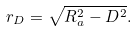Convert formula to latex. <formula><loc_0><loc_0><loc_500><loc_500>r _ { D } = \sqrt { R _ { a } ^ { 2 } - D ^ { 2 } } .</formula> 